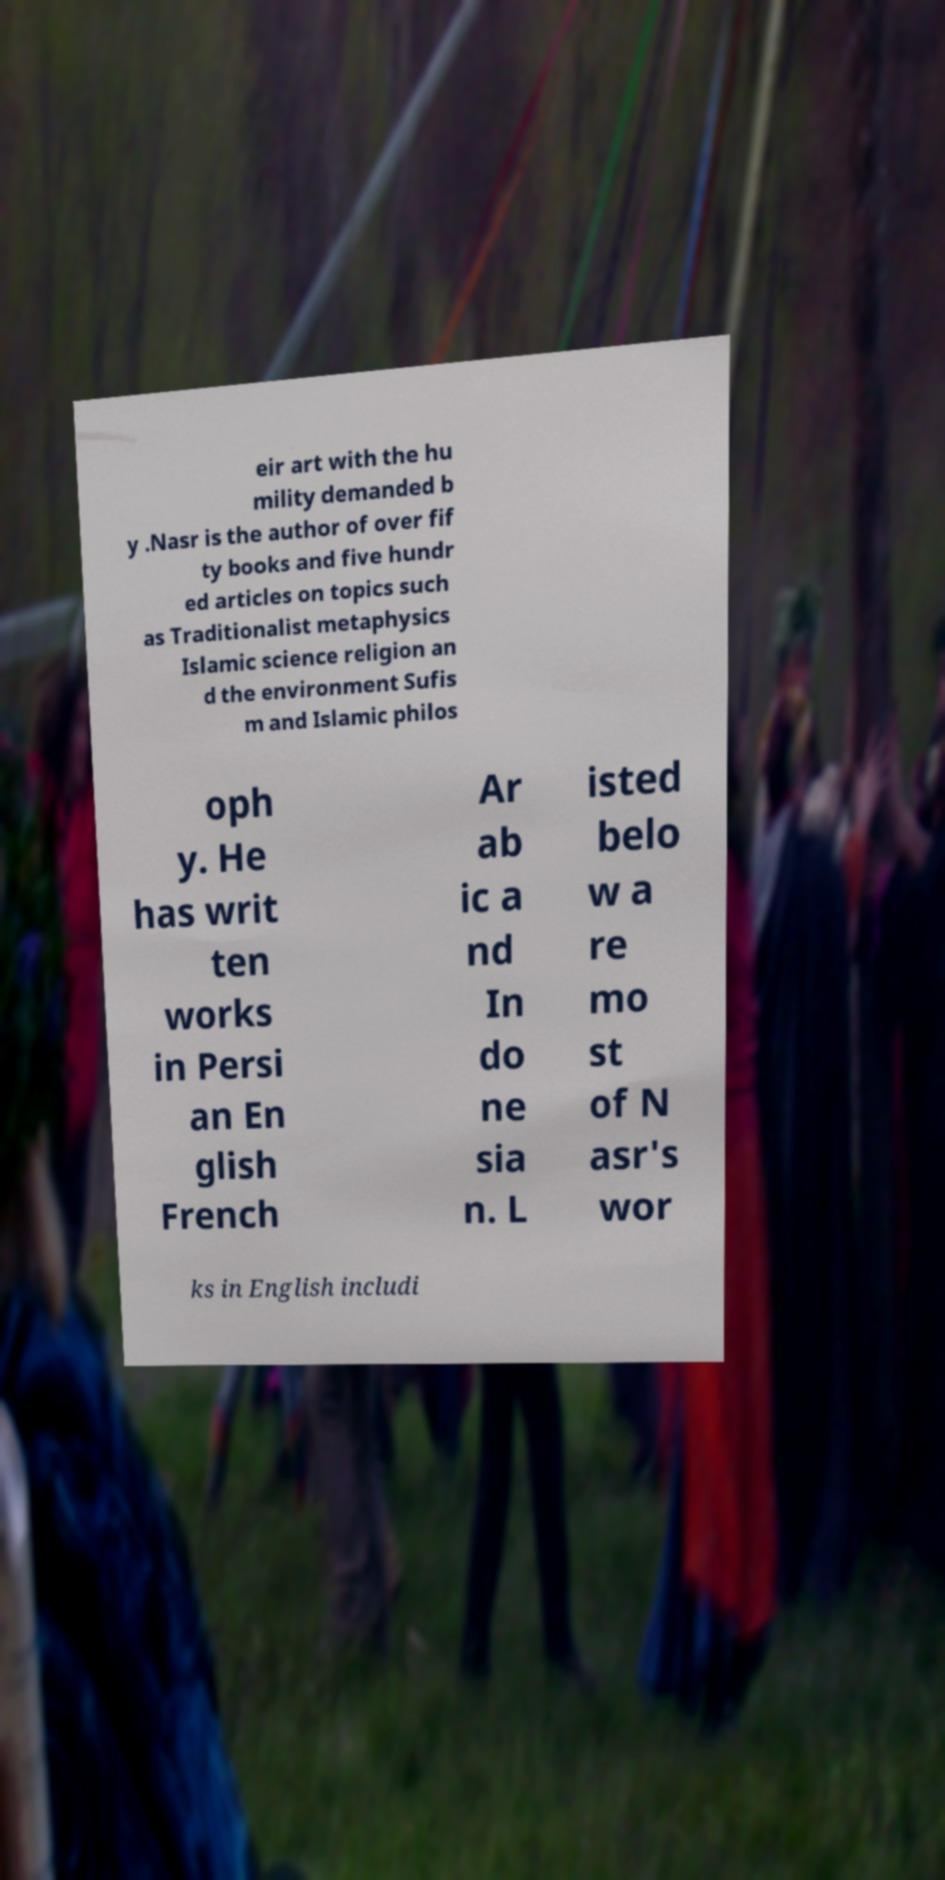Can you accurately transcribe the text from the provided image for me? eir art with the hu mility demanded b y .Nasr is the author of over fif ty books and five hundr ed articles on topics such as Traditionalist metaphysics Islamic science religion an d the environment Sufis m and Islamic philos oph y. He has writ ten works in Persi an En glish French Ar ab ic a nd In do ne sia n. L isted belo w a re mo st of N asr's wor ks in English includi 